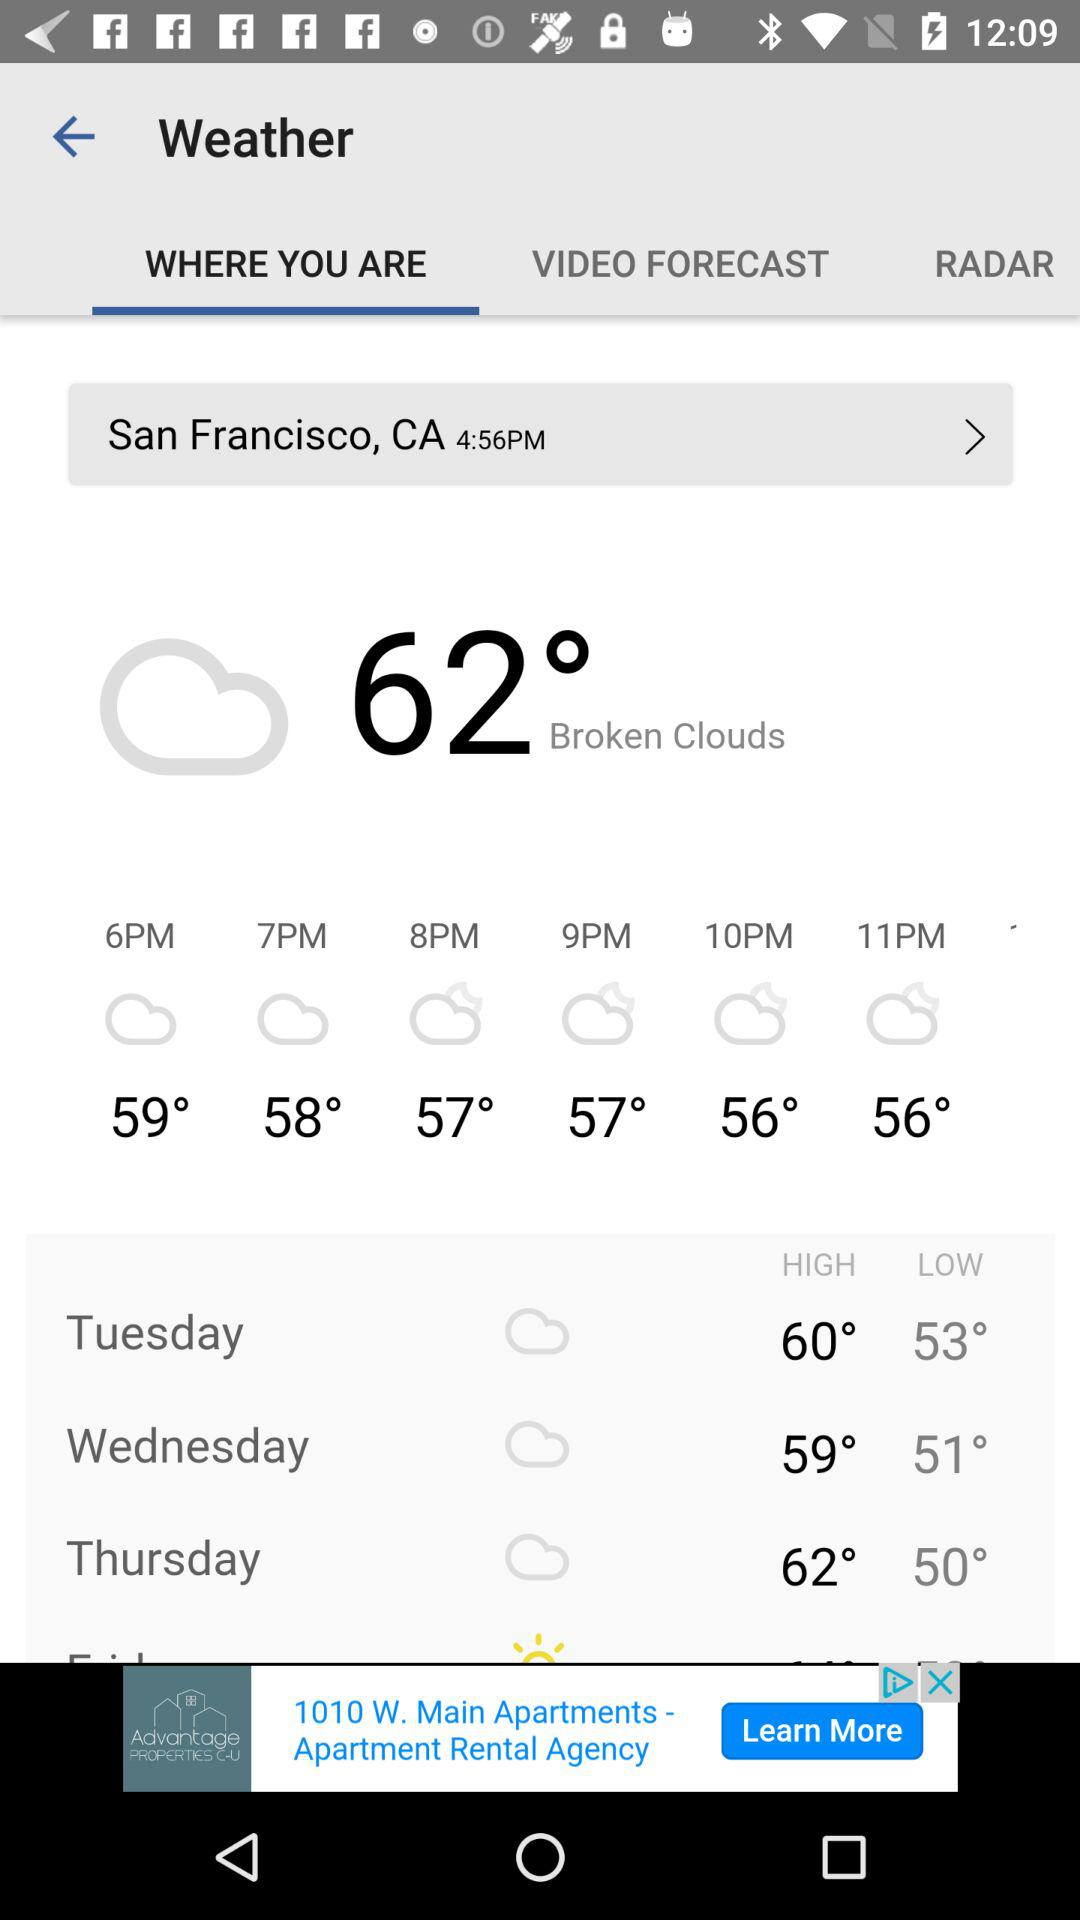How is the weather? The weather is cloudy. 